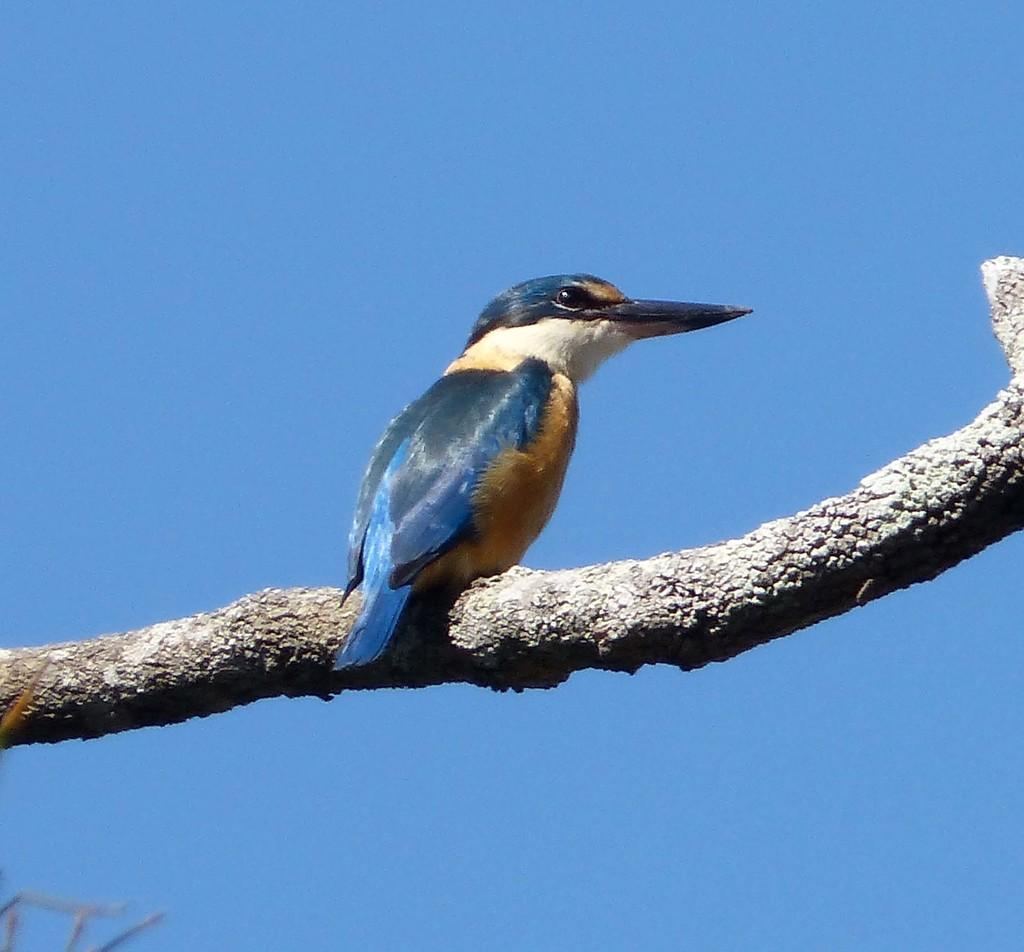What type of animal is in the image? There is a bird in the image. Where is the bird located? The bird is on a stem. What colors can be seen on the bird? The bird has blue, white, black, and orange colors. What can be seen in the background of the image? The sky is visible in the background of the image. What is the condition of the sky in the image? The sky is clear in the image. What type of box can be seen in the bird's stomach in the image? There is no box visible in the bird's stomach in the image. What type of pancake is the bird holding in its beak? The bird is not holding a pancake in its beak in the image. 